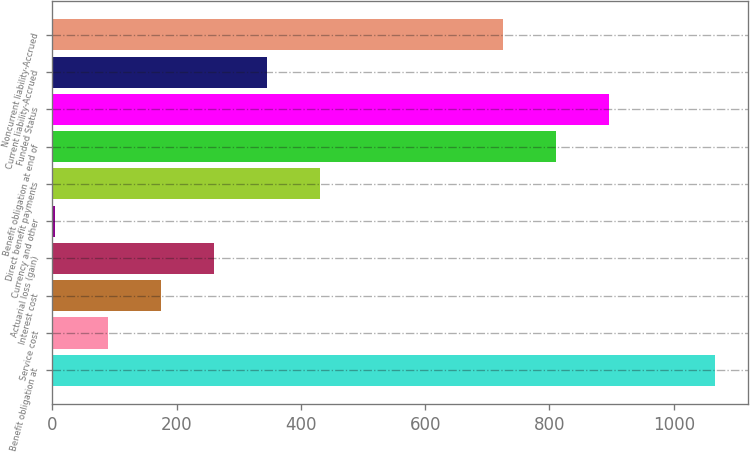<chart> <loc_0><loc_0><loc_500><loc_500><bar_chart><fcel>Benefit obligation at<fcel>Service cost<fcel>Interest cost<fcel>Actuarial loss (gain)<fcel>Currency and other<fcel>Direct benefit payments<fcel>Benefit obligation at end of<fcel>Funded Status<fcel>Current liability-Accrued<fcel>Noncurrent liability-Accrued<nl><fcel>1066.6<fcel>89.4<fcel>174.8<fcel>260.2<fcel>4<fcel>431<fcel>810.4<fcel>895.8<fcel>345.6<fcel>725<nl></chart> 